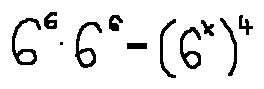Convert formula to latex. <formula><loc_0><loc_0><loc_500><loc_500>6 ^ { 6 } \cdot 6 ^ { 2 } = ( 6 ^ { x } ) ^ { 4 }</formula> 